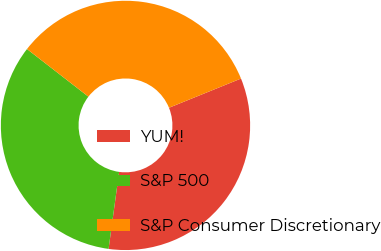Convert chart. <chart><loc_0><loc_0><loc_500><loc_500><pie_chart><fcel>YUM!<fcel>S&P 500<fcel>S&P Consumer Discretionary<nl><fcel>33.3%<fcel>33.33%<fcel>33.37%<nl></chart> 